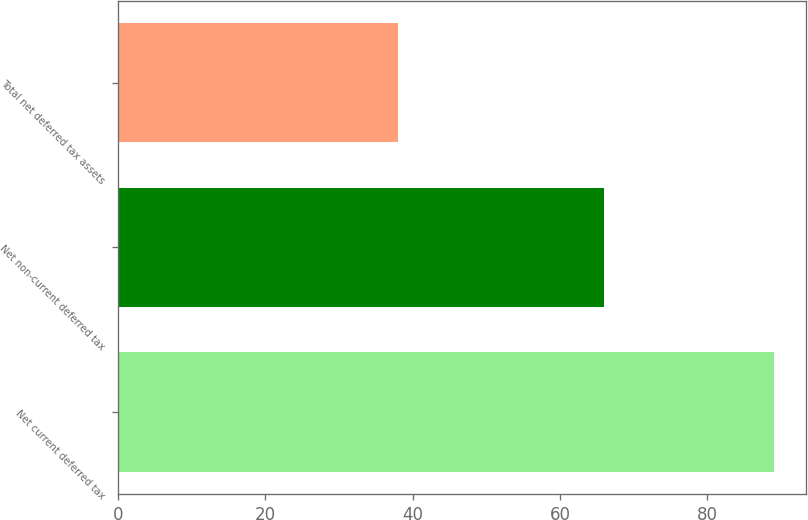<chart> <loc_0><loc_0><loc_500><loc_500><bar_chart><fcel>Net current deferred tax<fcel>Net non-current deferred tax<fcel>Total net deferred tax assets<nl><fcel>89<fcel>66<fcel>38<nl></chart> 